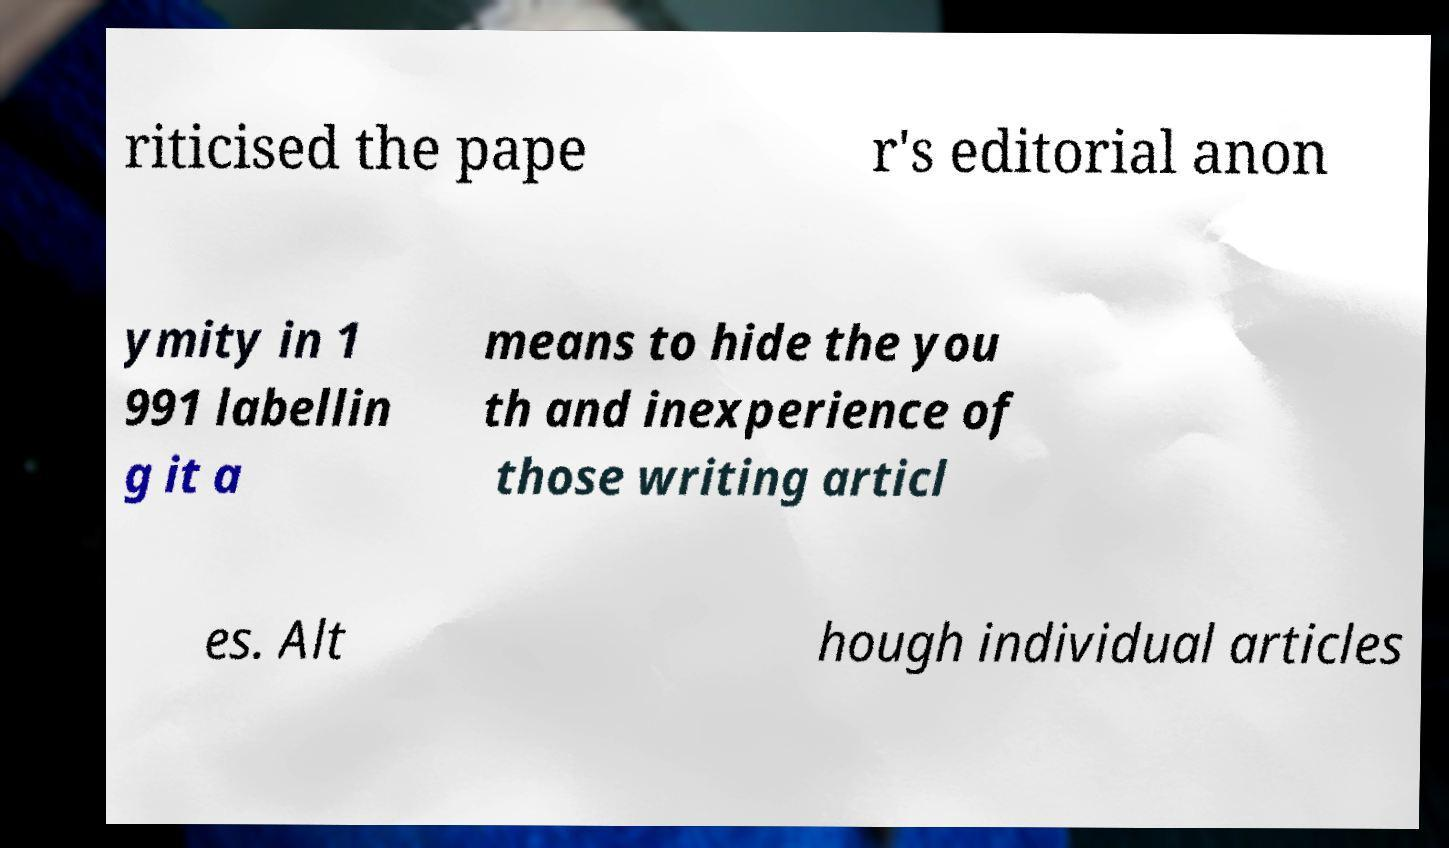Can you accurately transcribe the text from the provided image for me? riticised the pape r's editorial anon ymity in 1 991 labellin g it a means to hide the you th and inexperience of those writing articl es. Alt hough individual articles 